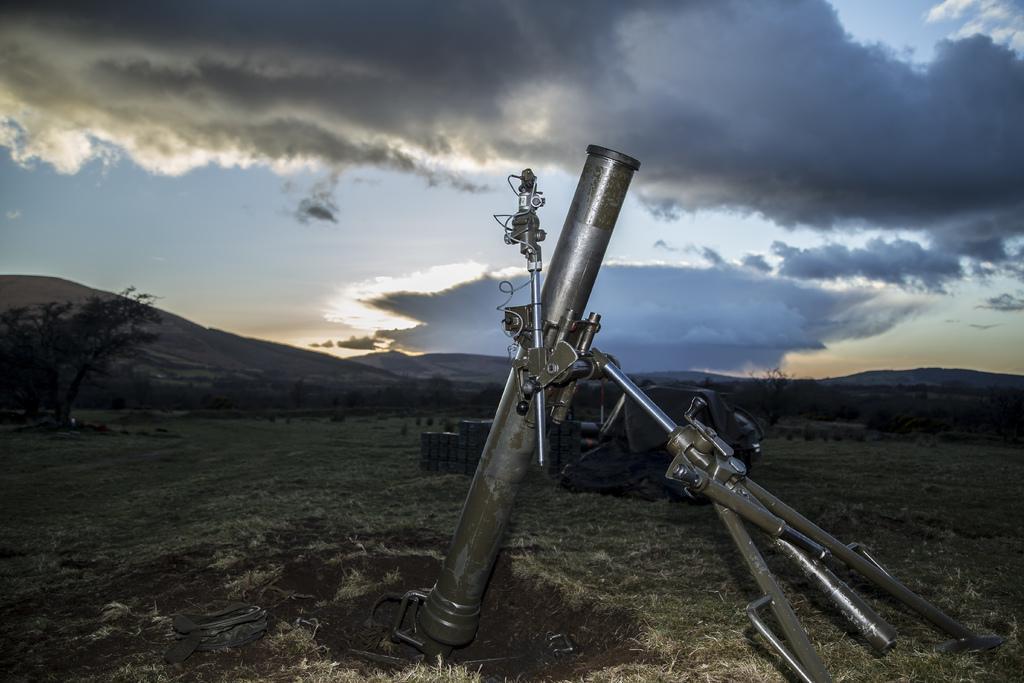Can you describe this image briefly? In the center of the image there is a weapon on the ground. In the background we can see trees, hills, sky and clouds. 